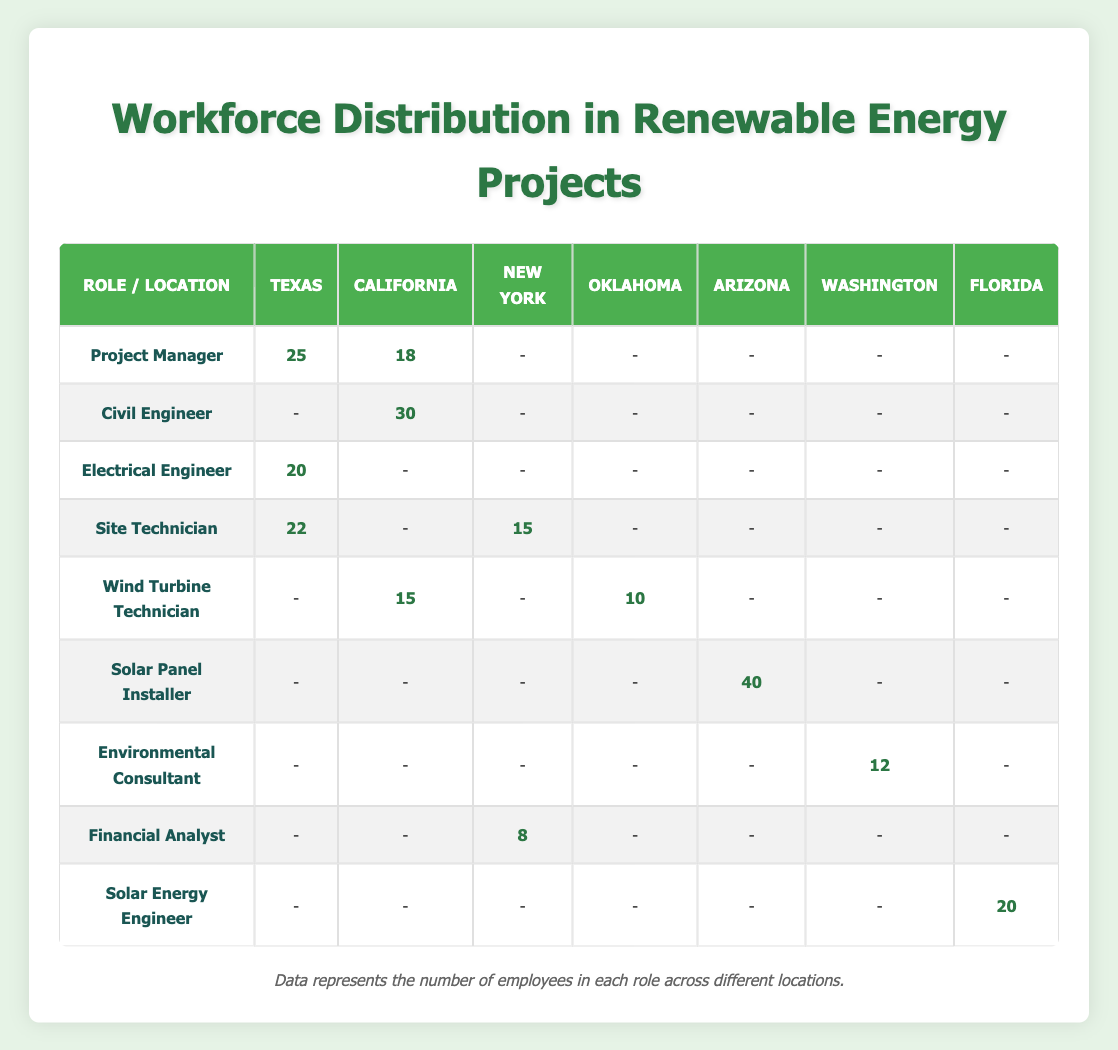What is the total number of Site Technicians in Texas? Looking at the table, the count of Site Technicians in Texas is 22. Therefore, the total number of Site Technicians in Texas is simply this one value.
Answer: 22 Which role has the highest count in Arizona? In the table, the only role listed under Arizona is Solar Panel Installer, with a count of 40. Since it’s the only role, it automatically has the highest count in that location.
Answer: Solar Panel Installer Is there an Electrical Engineer located in New York? By examining the table, I can see that there is no entry for an Electrical Engineer listed under New York, as the counts only show data for Texas. Thus, the answer is directly in the data.
Answer: No What is the combined total of Project Managers in Texas and California? In Texas, the count of Project Managers is 25, and in California, it’s 18. Adding these two values gives us 25 + 18 = 43. Thus, the combined total of Project Managers in these two locations is found through simple addition.
Answer: 43 How many more Civil Engineers are there in California than Financial Analysts in New York? Looking at the counts, Civil Engineers in California are 30 and Financial Analysts in New York are 8. The difference is calculated as 30 - 8 = 22. This requires subtraction to find how many more Civil Engineers there are.
Answer: 22 Are there any Environmental Consultants in Texas? Checking the table shows that there is no entry for Environmental Consultants in Texas, which can be observed by looking at the row for this role. Therefore, the response is found directly in the data.
Answer: No What is the total number of Wind Turbine Technicians across California and Oklahoma? From the table, I see there are 15 Wind Turbine Technicians in California and 10 in Oklahoma. To find the total, I sum these two numbers: 15 + 10 = 25. Therefore, the total across these two locations is established through addition.
Answer: 25 Which state has the highest number of Solar Energy Engineers, and what is the count? The only entry for Solar Energy Engineers appears under Florida, with a count of 20. Since there are no other entries for this role in different states, Florida has the highest count as it is the only state listed.
Answer: Florida, 20 